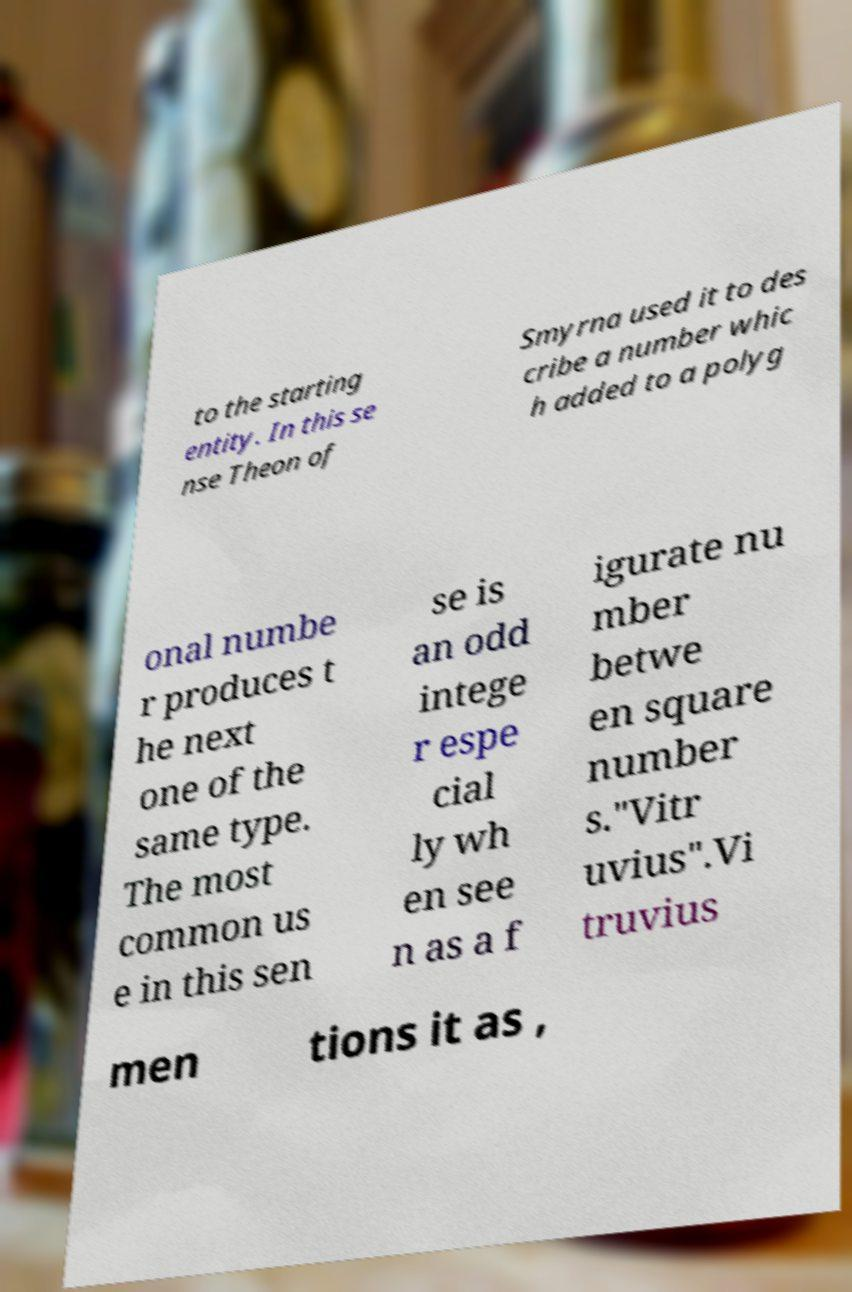What messages or text are displayed in this image? I need them in a readable, typed format. to the starting entity. In this se nse Theon of Smyrna used it to des cribe a number whic h added to a polyg onal numbe r produces t he next one of the same type. The most common us e in this sen se is an odd intege r espe cial ly wh en see n as a f igurate nu mber betwe en square number s."Vitr uvius".Vi truvius men tions it as , 